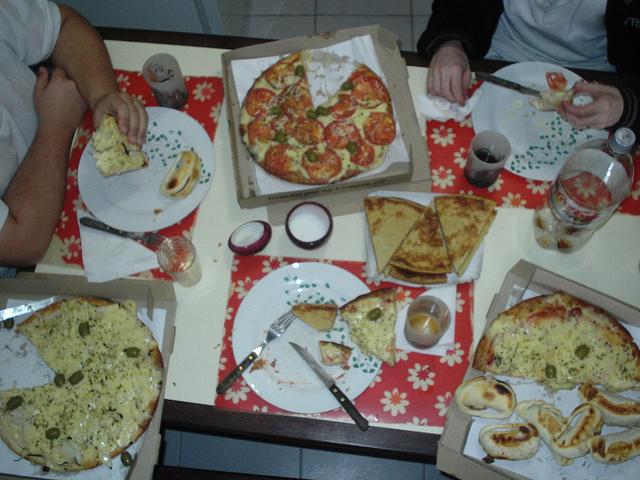Which pizza is pepperoni?
Write a very short answer. Top. Is the food eaten?
Be succinct. Yes. What food is next to the knife?
Give a very brief answer. Pizza. Would a vegetarian eat this?
Concise answer only. Yes. Does this food look appetizing?
Keep it brief. Yes. Is there a lot of cheese on the pizzas?
Answer briefly. Yes. Are there different types of pizza?
Write a very short answer. Yes. Has the meal started yet?
Be succinct. Yes. What kind of surface is the food on?
Give a very brief answer. Table. How many slices of pizza?
Give a very brief answer. Many. 